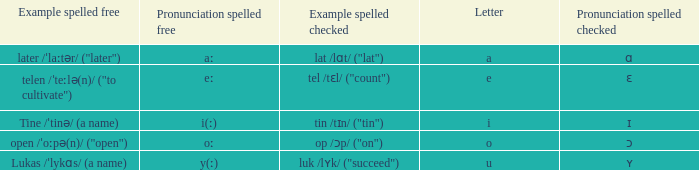What is Letter, when Example Spelled Checked is "tin /tɪn/ ("tin")"? I. 